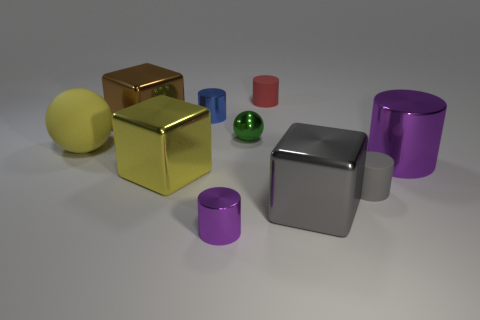Subtract all brown cylinders. Subtract all gray blocks. How many cylinders are left? 5 Subtract all cubes. How many objects are left? 7 Add 2 tiny blue cylinders. How many tiny blue cylinders are left? 3 Add 7 big yellow spheres. How many big yellow spheres exist? 8 Subtract 0 red spheres. How many objects are left? 10 Subtract all small blue rubber cylinders. Subtract all small green metal balls. How many objects are left? 9 